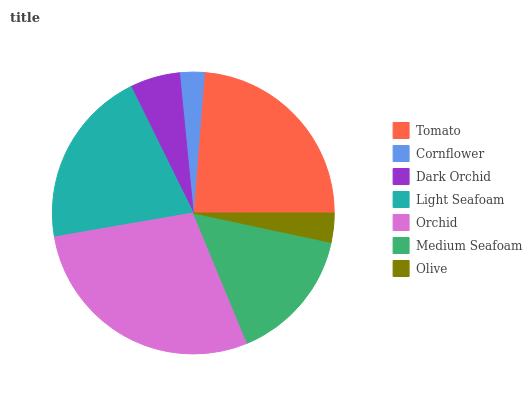Is Cornflower the minimum?
Answer yes or no. Yes. Is Orchid the maximum?
Answer yes or no. Yes. Is Dark Orchid the minimum?
Answer yes or no. No. Is Dark Orchid the maximum?
Answer yes or no. No. Is Dark Orchid greater than Cornflower?
Answer yes or no. Yes. Is Cornflower less than Dark Orchid?
Answer yes or no. Yes. Is Cornflower greater than Dark Orchid?
Answer yes or no. No. Is Dark Orchid less than Cornflower?
Answer yes or no. No. Is Medium Seafoam the high median?
Answer yes or no. Yes. Is Medium Seafoam the low median?
Answer yes or no. Yes. Is Olive the high median?
Answer yes or no. No. Is Olive the low median?
Answer yes or no. No. 